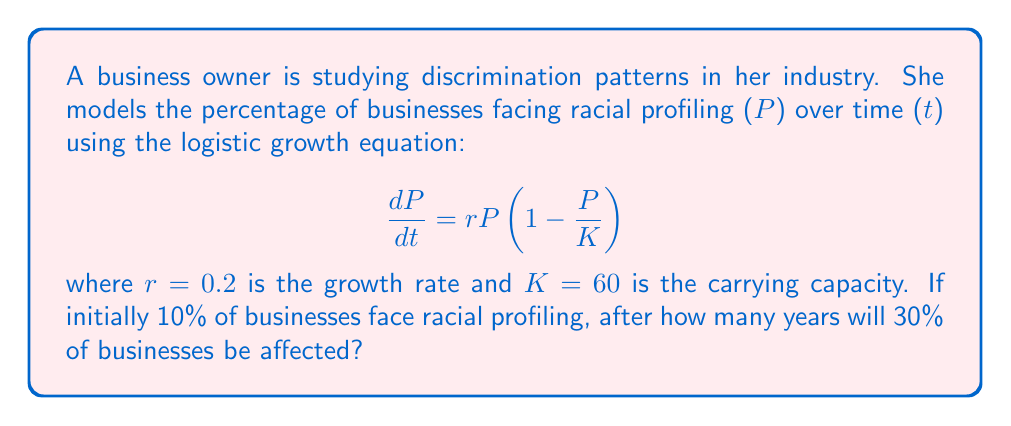Can you answer this question? To solve this problem, we'll use the analytical solution of the logistic growth equation:

1) The solution to the logistic equation is:

   $$P(t) = \frac{K}{1 + (\frac{K}{P_0} - 1)e^{-rt}}$$

   where $P_0$ is the initial percentage.

2) We're given:
   $K = 60$, $r = 0.2$, $P_0 = 10$, and we want to find $t$ when $P(t) = 30$

3) Substituting these values into the equation:

   $$30 = \frac{60}{1 + (\frac{60}{10} - 1)e^{-0.2t}}$$

4) Simplifying:
   $$30 = \frac{60}{1 + 5e^{-0.2t}}$$

5) Multiplying both sides by $(1 + 5e^{-0.2t})$:
   $$30(1 + 5e^{-0.2t}) = 60$$

6) Expanding:
   $$30 + 150e^{-0.2t} = 60$$

7) Subtracting 30 from both sides:
   $$150e^{-0.2t} = 30$$

8) Dividing both sides by 150:
   $$e^{-0.2t} = \frac{1}{5}$$

9) Taking natural log of both sides:
   $$-0.2t = \ln(\frac{1}{5}) = -\ln(5)$$

10) Solving for $t$:
    $$t = \frac{\ln(5)}{0.2} \approx 8.05$$

Therefore, it will take approximately 8.05 years for 30% of businesses to be affected by racial profiling.
Answer: 8.05 years 